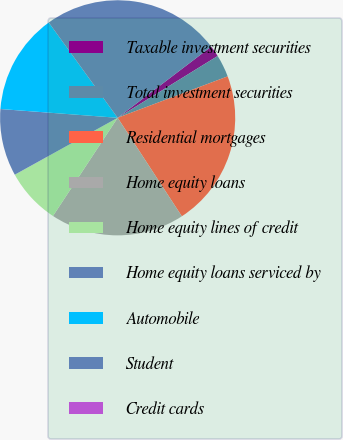Convert chart to OTSL. <chart><loc_0><loc_0><loc_500><loc_500><pie_chart><fcel>Taxable investment securities<fcel>Total investment securities<fcel>Residential mortgages<fcel>Home equity loans<fcel>Home equity lines of credit<fcel>Home equity loans serviced by<fcel>Automobile<fcel>Student<fcel>Credit cards<nl><fcel>1.54%<fcel>3.08%<fcel>21.54%<fcel>18.46%<fcel>7.69%<fcel>9.23%<fcel>13.85%<fcel>24.61%<fcel>0.0%<nl></chart> 